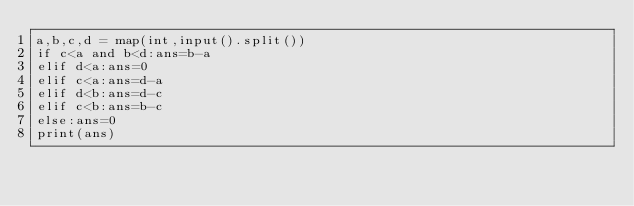Convert code to text. <code><loc_0><loc_0><loc_500><loc_500><_Python_>a,b,c,d = map(int,input().split())
if c<a and b<d:ans=b-a
elif d<a:ans=0
elif c<a:ans=d-a
elif d<b:ans=d-c
elif c<b:ans=b-c
else:ans=0
print(ans)</code> 